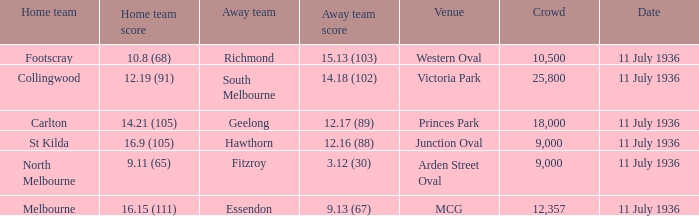16 (88)? Hawthorn. Parse the full table. {'header': ['Home team', 'Home team score', 'Away team', 'Away team score', 'Venue', 'Crowd', 'Date'], 'rows': [['Footscray', '10.8 (68)', 'Richmond', '15.13 (103)', 'Western Oval', '10,500', '11 July 1936'], ['Collingwood', '12.19 (91)', 'South Melbourne', '14.18 (102)', 'Victoria Park', '25,800', '11 July 1936'], ['Carlton', '14.21 (105)', 'Geelong', '12.17 (89)', 'Princes Park', '18,000', '11 July 1936'], ['St Kilda', '16.9 (105)', 'Hawthorn', '12.16 (88)', 'Junction Oval', '9,000', '11 July 1936'], ['North Melbourne', '9.11 (65)', 'Fitzroy', '3.12 (30)', 'Arden Street Oval', '9,000', '11 July 1936'], ['Melbourne', '16.15 (111)', 'Essendon', '9.13 (67)', 'MCG', '12,357', '11 July 1936']]} 